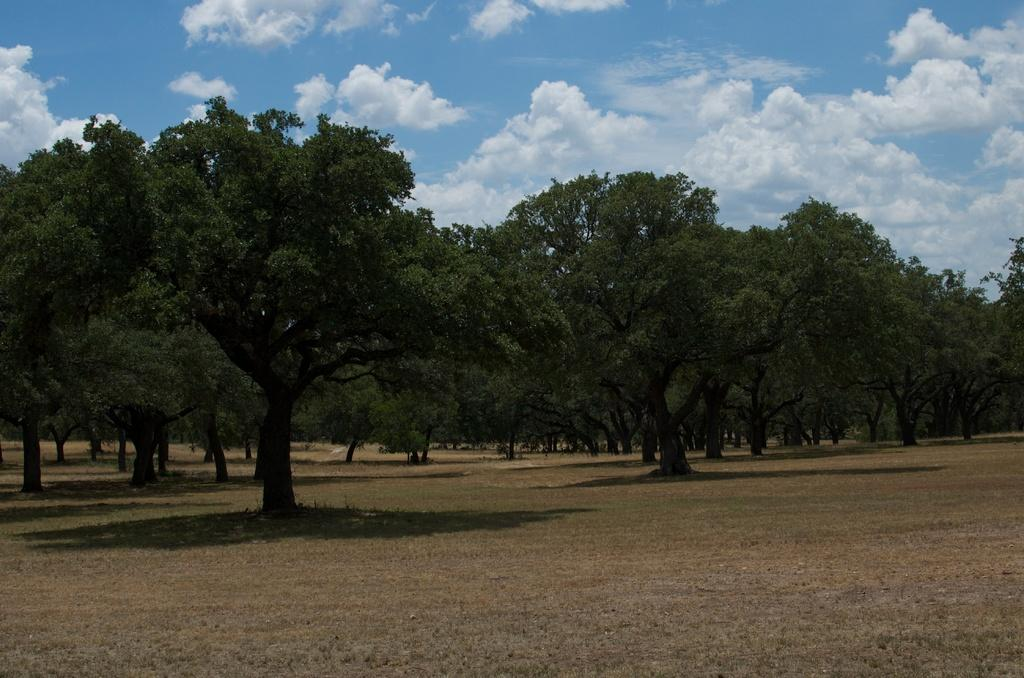What type of vegetation can be seen in the image? There are trees in the image. What part of the natural environment is visible in the image? The sky is visible in the background of the image. What religion is being practiced in the image? There is no indication of any religious practice in the image; it only features trees and the sky. 